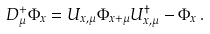Convert formula to latex. <formula><loc_0><loc_0><loc_500><loc_500>D ^ { + } _ { \mu } \Phi _ { x } = U _ { x , \mu } \Phi _ { x + \mu } U ^ { \dagger } _ { x , \mu } - \Phi _ { x } \, .</formula> 